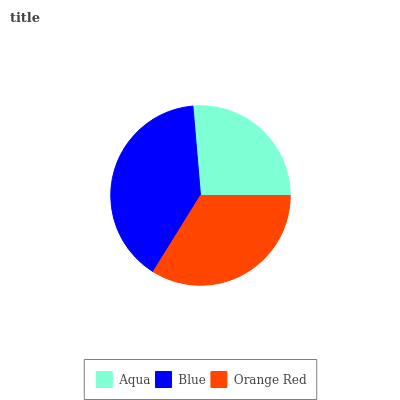Is Aqua the minimum?
Answer yes or no. Yes. Is Blue the maximum?
Answer yes or no. Yes. Is Orange Red the minimum?
Answer yes or no. No. Is Orange Red the maximum?
Answer yes or no. No. Is Blue greater than Orange Red?
Answer yes or no. Yes. Is Orange Red less than Blue?
Answer yes or no. Yes. Is Orange Red greater than Blue?
Answer yes or no. No. Is Blue less than Orange Red?
Answer yes or no. No. Is Orange Red the high median?
Answer yes or no. Yes. Is Orange Red the low median?
Answer yes or no. Yes. Is Aqua the high median?
Answer yes or no. No. Is Aqua the low median?
Answer yes or no. No. 